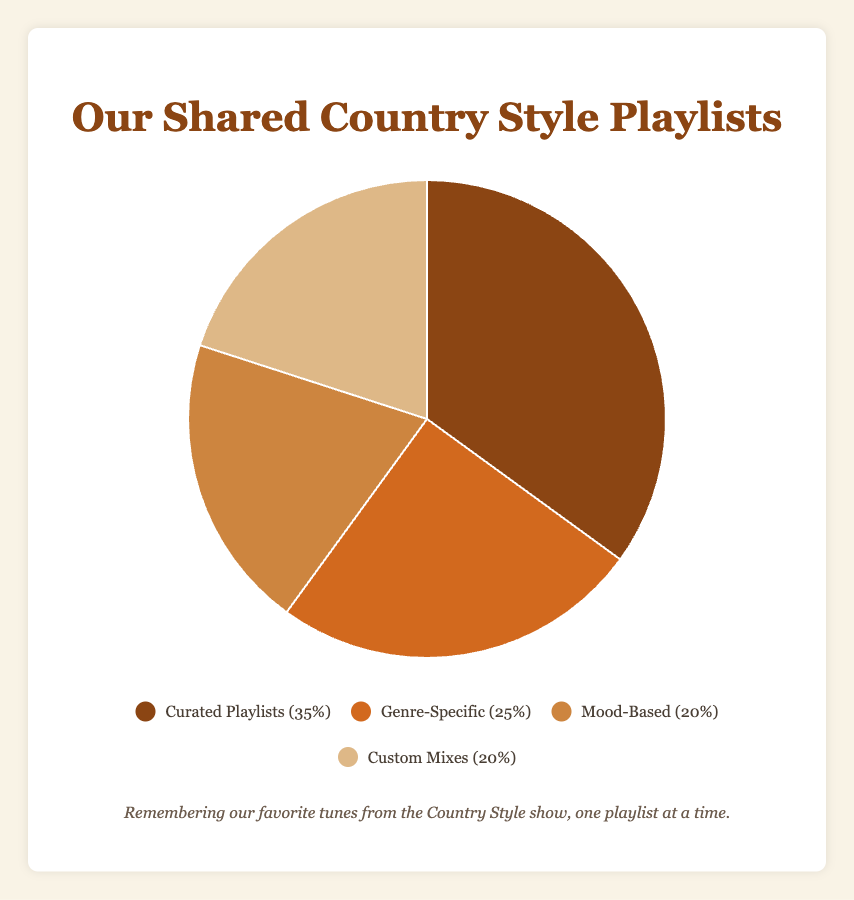Which playlist type has the largest percentage? The Curated Playlists have the highest percentage as indicated by the largest slice in the pie chart.
Answer: Curated Playlists What is the combined percentage of Mood-Based and Custom Mixes playlists? The percentage for Mood-Based is 20% and for Custom Mixes is also 20%. Summing them up gives 20% + 20% = 40%.
Answer: 40% How does the percentage of Genre-Specific playlists compare to Custom Mixes? The Genre-Specific playlists hold 25%, while Custom Mixes hold 20%. 25% is more than 20%.
Answer: Genre-Specific is more Which slice in the pie chart represents the Curated Playlists? The Curated Playlists are represented by the largest slice in the pie chart, often positioned prominently in the figure.
Answer: Largest slice Is the percentage of Custom Mixes greater than, less than, or equal to Mood-Based playlists? The percentage of Custom Mixes is equal to Mood-Based playlists, both have 20%.
Answer: Equal to How many types of playlists collectively make up 70% of the total? Adding Curated Playlists (35%) and Genre-Specific (25%) gives 35% + 25% = 60%. Adding Mood-Based (20%) next gives us 60% + 20% = 80%. Hence, Curated Playlists and Genre-Specific alone sum to 60%, and adding any one more (Mood-Based or Custom Mixes) surpasses 70%.
Answer: 3 types Which playlist type has more percentage, Mood-Based or Genre-Specific? Genre-Specific playlists have a percentage of 25%, while Mood-Based has 20%. 25% is greater than 20%.
Answer: Genre-Specific What fraction of the pie chart is taken up by Custom Mixes and Mood-Based combined? Custom Mixes (20%) plus Mood-Based (20%) total to 40%. So, the fraction is 40/100 or 2/5.
Answer: 2/5 